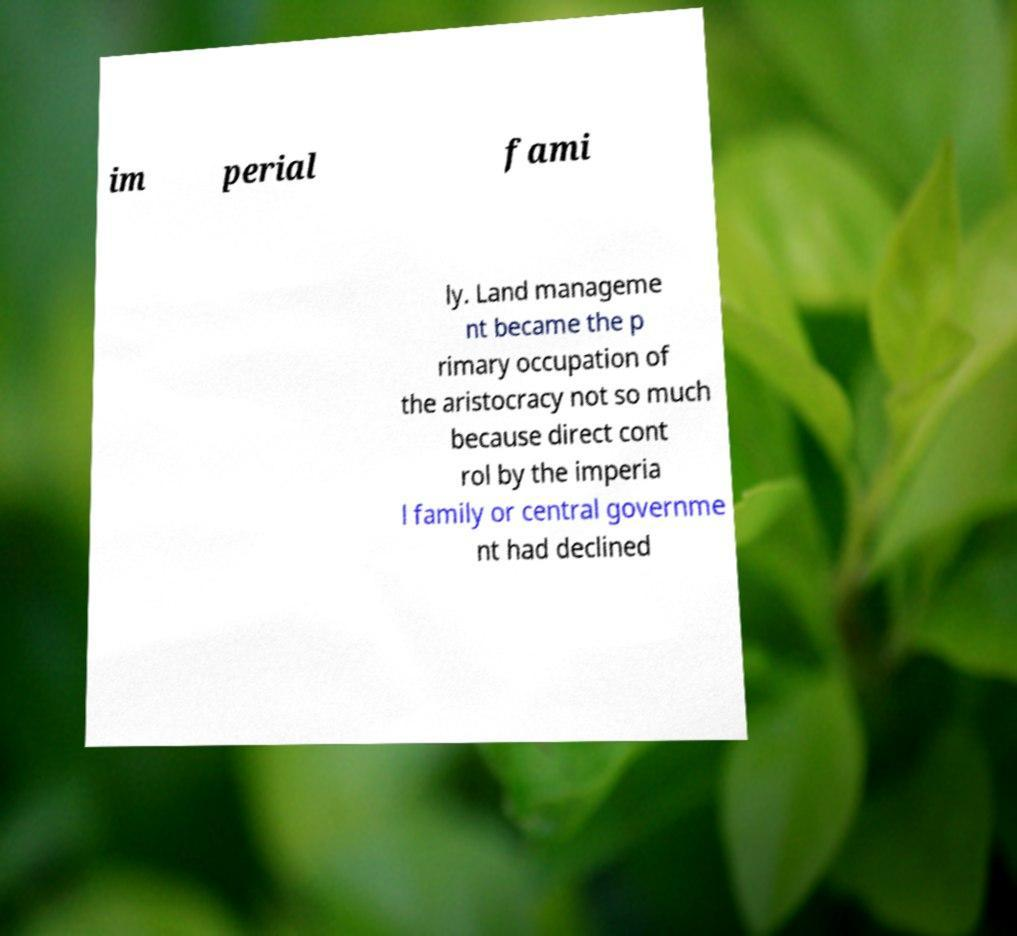I need the written content from this picture converted into text. Can you do that? im perial fami ly. Land manageme nt became the p rimary occupation of the aristocracy not so much because direct cont rol by the imperia l family or central governme nt had declined 